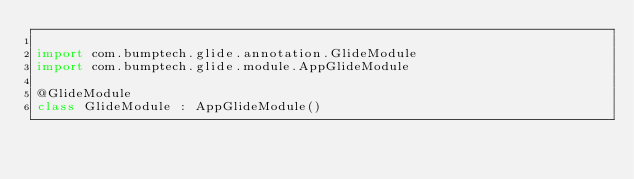<code> <loc_0><loc_0><loc_500><loc_500><_Kotlin_>
import com.bumptech.glide.annotation.GlideModule
import com.bumptech.glide.module.AppGlideModule

@GlideModule
class GlideModule : AppGlideModule()</code> 